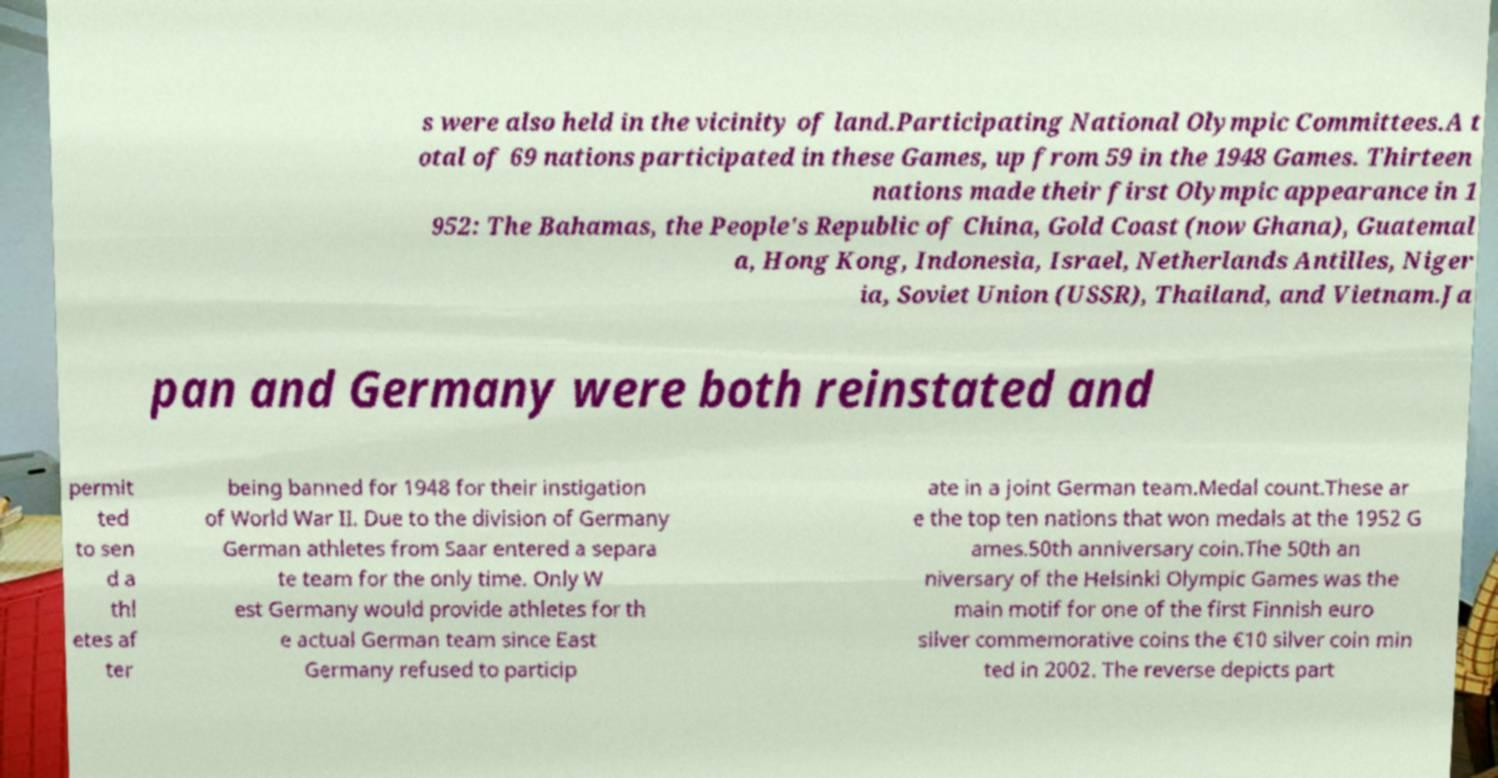Can you read and provide the text displayed in the image?This photo seems to have some interesting text. Can you extract and type it out for me? s were also held in the vicinity of land.Participating National Olympic Committees.A t otal of 69 nations participated in these Games, up from 59 in the 1948 Games. Thirteen nations made their first Olympic appearance in 1 952: The Bahamas, the People's Republic of China, Gold Coast (now Ghana), Guatemal a, Hong Kong, Indonesia, Israel, Netherlands Antilles, Niger ia, Soviet Union (USSR), Thailand, and Vietnam.Ja pan and Germany were both reinstated and permit ted to sen d a thl etes af ter being banned for 1948 for their instigation of World War II. Due to the division of Germany German athletes from Saar entered a separa te team for the only time. Only W est Germany would provide athletes for th e actual German team since East Germany refused to particip ate in a joint German team.Medal count.These ar e the top ten nations that won medals at the 1952 G ames.50th anniversary coin.The 50th an niversary of the Helsinki Olympic Games was the main motif for one of the first Finnish euro silver commemorative coins the €10 silver coin min ted in 2002. The reverse depicts part 